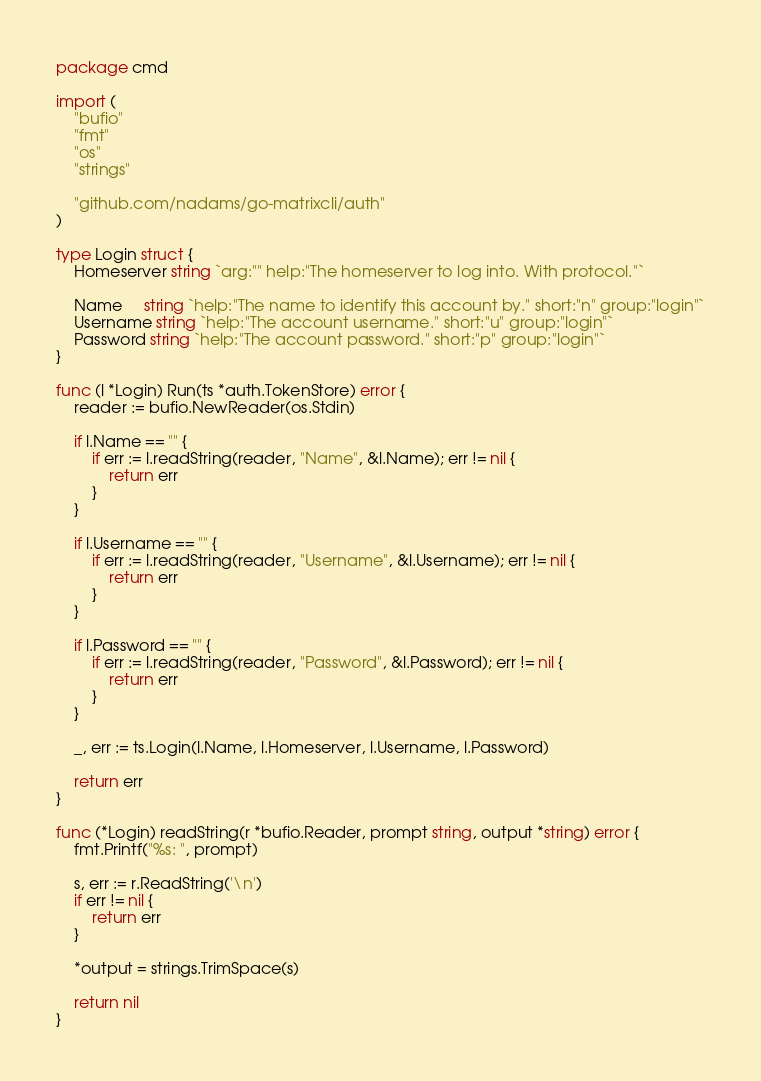<code> <loc_0><loc_0><loc_500><loc_500><_Go_>package cmd

import (
	"bufio"
	"fmt"
	"os"
	"strings"

	"github.com/nadams/go-matrixcli/auth"
)

type Login struct {
	Homeserver string `arg:"" help:"The homeserver to log into. With protocol."`

	Name     string `help:"The name to identify this account by." short:"n" group:"login"`
	Username string `help:"The account username." short:"u" group:"login"`
	Password string `help:"The account password." short:"p" group:"login"`
}

func (l *Login) Run(ts *auth.TokenStore) error {
	reader := bufio.NewReader(os.Stdin)

	if l.Name == "" {
		if err := l.readString(reader, "Name", &l.Name); err != nil {
			return err
		}
	}

	if l.Username == "" {
		if err := l.readString(reader, "Username", &l.Username); err != nil {
			return err
		}
	}

	if l.Password == "" {
		if err := l.readString(reader, "Password", &l.Password); err != nil {
			return err
		}
	}

	_, err := ts.Login(l.Name, l.Homeserver, l.Username, l.Password)

	return err
}

func (*Login) readString(r *bufio.Reader, prompt string, output *string) error {
	fmt.Printf("%s: ", prompt)

	s, err := r.ReadString('\n')
	if err != nil {
		return err
	}

	*output = strings.TrimSpace(s)

	return nil
}
</code> 